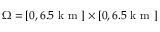Convert formula to latex. <formula><loc_0><loc_0><loc_500><loc_500>\Omega = [ 0 , 6 . 5 k m ] \times [ 0 , 6 . 5 k m ]</formula> 